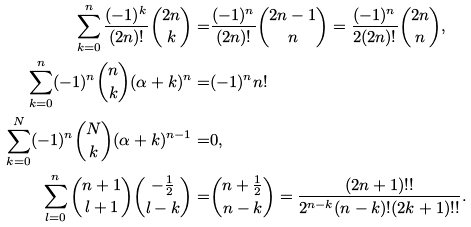<formula> <loc_0><loc_0><loc_500><loc_500>\sum ^ { n } _ { k = 0 } \frac { ( - 1 ) ^ { k } } { ( 2 n ) ! } \binom { 2 n } { k } = & \frac { ( - 1 ) ^ { n } } { ( 2 n ) ! } \binom { 2 n - 1 } { n } = \frac { ( - 1 ) ^ { n } } { 2 ( 2 n ) ! } \binom { 2 n } { n } , \\ \sum ^ { n } _ { k = 0 } ( - 1 ) ^ { n } \binom { n } { k } ( \alpha + k ) ^ { n } = & ( - 1 ) ^ { n } n ! \\ \sum ^ { N } _ { k = 0 } ( - 1 ) ^ { n } \binom { N } { k } ( \alpha + k ) ^ { n - 1 } = & 0 , \\ \sum ^ { n } _ { l = 0 } \binom { n + 1 } { l + 1 } \binom { - \frac { 1 } { 2 } } { l - k } = & \binom { n + \frac { 1 } { 2 } } { n - k } = \frac { ( 2 n + 1 ) ! ! } { 2 ^ { n - k } ( n - k ) ! ( 2 k + 1 ) ! ! } .</formula> 